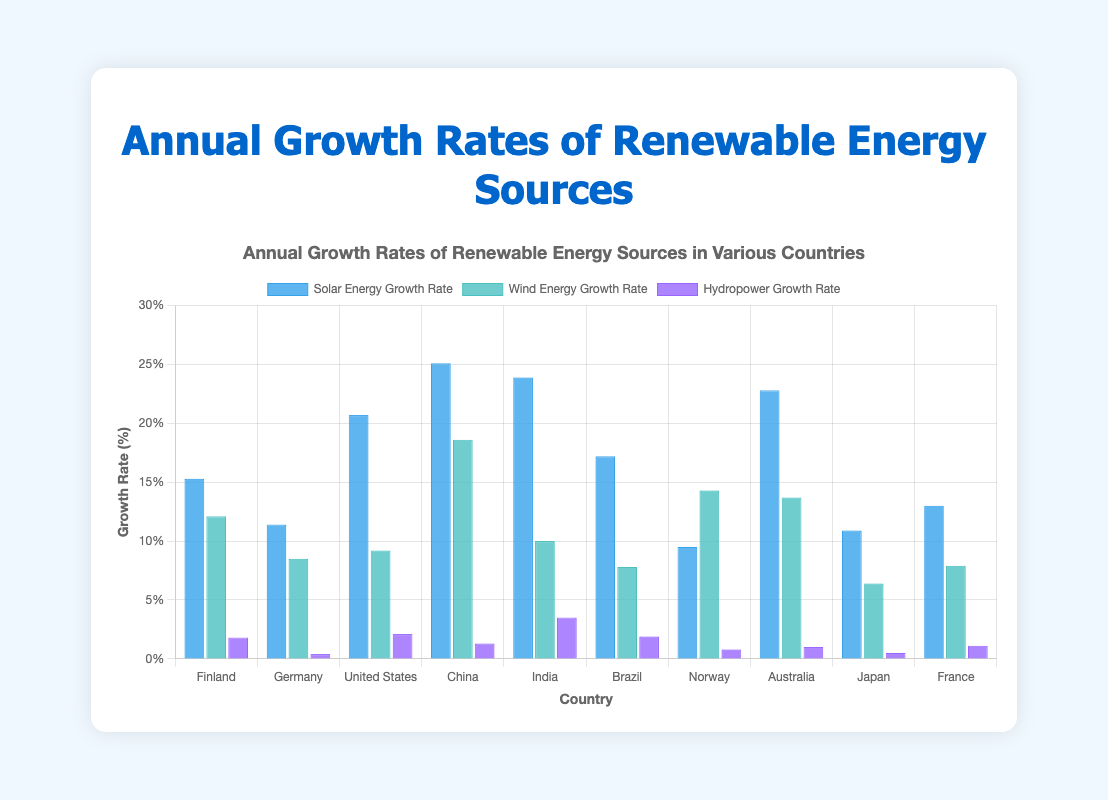Which country has the highest growth rate in solar energy? To find the country with the highest solar energy growth rate, look for the tallest blue bar among the bars labeled "Solar Energy Growth Rate." China has the highest solar energy growth rate.
Answer: China Which country has the smallest growth rate in hydropower? To find the country with the smallest hydropower growth rate, look for the shortest purple bar among the bars labeled "Hydropower Growth Rate." Germany has the smallest hydropower growth rate.
Answer: Germany What is the average growth rate of solar energy across all countries? To calculate the average growth rate of solar energy, sum up the solar growth rates of all countries and divide by the number of countries. Sum = 15.3 + 11.4 + 20.7 + 25.1 + 23.9 + 17.2 + 9.5 + 22.8 + 10.9 + 13.0 = 169.8. Average = 169.8 / 10 = 16.98.
Answer: 16.98 Which country has a higher growth rate in wind energy, Brazil or Japan? Compare the height of the teal bars for Brazil and Japan, labeled "Wind Energy Growth Rate." Brazil has a growth rate of 7.8% and Japan has 6.4%. Brazil has a higher growth rate.
Answer: Brazil What is the total growth rate of renewable energy (sum of solar, wind, and hydropower) for India? To find the total growth rate for India, sum India's growth rates in solar, wind, and hydropower. Solar: 23.9%, Wind: 10.0%, Hydro: 3.5%. Total = 23.9 + 10.0 + 3.5 = 37.4%.
Answer: 37.4% Which country has the highest combined growth rate for all three renewable energy sources? To determine the highest combined growth rate, sum the growth rates of solar, wind, and hydropower for each country and find the highest value. Highest combined rate belongs to China (25.1 + 18.6 + 1.3 = 45.0).
Answer: China What is the difference in wind energy growth rates between Finland and Norway? Subtract Norway's wind energy growth rate from Finland's wind energy growth rate. Finland: 12.1%, Norway: 14.3%. Difference = 14.3 - 12.1 = 2.2%.
Answer: 2.2% Which country has the closest growth rate in wind energy to the average growth rate of wind energy across all countries? First, calculate the average wind energy growth rate: (12.1 + 8.5 + 9.2 + 18.6 + 10.0 + 7.8 + 14.3 + 13.7 + 6.4 + 7.9) / 10 = 10.85%. Then, compare each country's wind energy growth rate to this average to find the closest one. Germany and India both have rates closest to the average (8.5% and 10.0% respectively), but India's is slightly closer.
Answer: India What is the median growth rate for hydropower across all countries? To find the median, list the hydropower growth rates in ascending order and find the middle value. Sorted: [0.4, 0.5, 0.8, 1.0, 1.1, 1.3, 1.8, 1.9, 2.1, 3.5]. The median is the average of the 5th and 6th values: (1.1 + 1.3) / 2 = 1.2%.
Answer: 1.2% Which country shows the largest disparity between its solar energy and wind energy growth rates? For each country, calculate the absolute difference between solar and wind energy growth rates and find the largest disparity. China has the largest difference:
Answer: China If only the top 3 countries in solar energy growth rates were considered, what would their combined average growth rate be? Identify the top 3 solar energy growth rates: China: 25.1%, India: 23.9%, Australia: 22.8%. Sum these rates and divide by 3: (25.1 + 23.9 + 22.8) / 3 = 23.93%.
Answer: 23.93% 